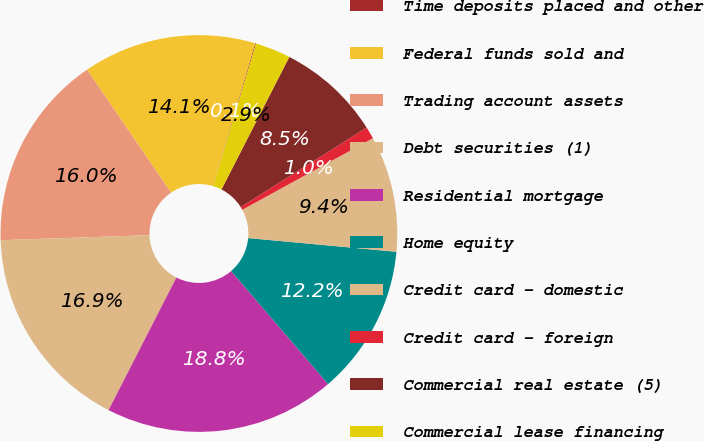<chart> <loc_0><loc_0><loc_500><loc_500><pie_chart><fcel>Time deposits placed and other<fcel>Federal funds sold and<fcel>Trading account assets<fcel>Debt securities (1)<fcel>Residential mortgage<fcel>Home equity<fcel>Credit card - domestic<fcel>Credit card - foreign<fcel>Commercial real estate (5)<fcel>Commercial lease financing<nl><fcel>0.07%<fcel>14.12%<fcel>16.0%<fcel>16.94%<fcel>18.81%<fcel>12.25%<fcel>9.44%<fcel>1.0%<fcel>8.5%<fcel>2.88%<nl></chart> 